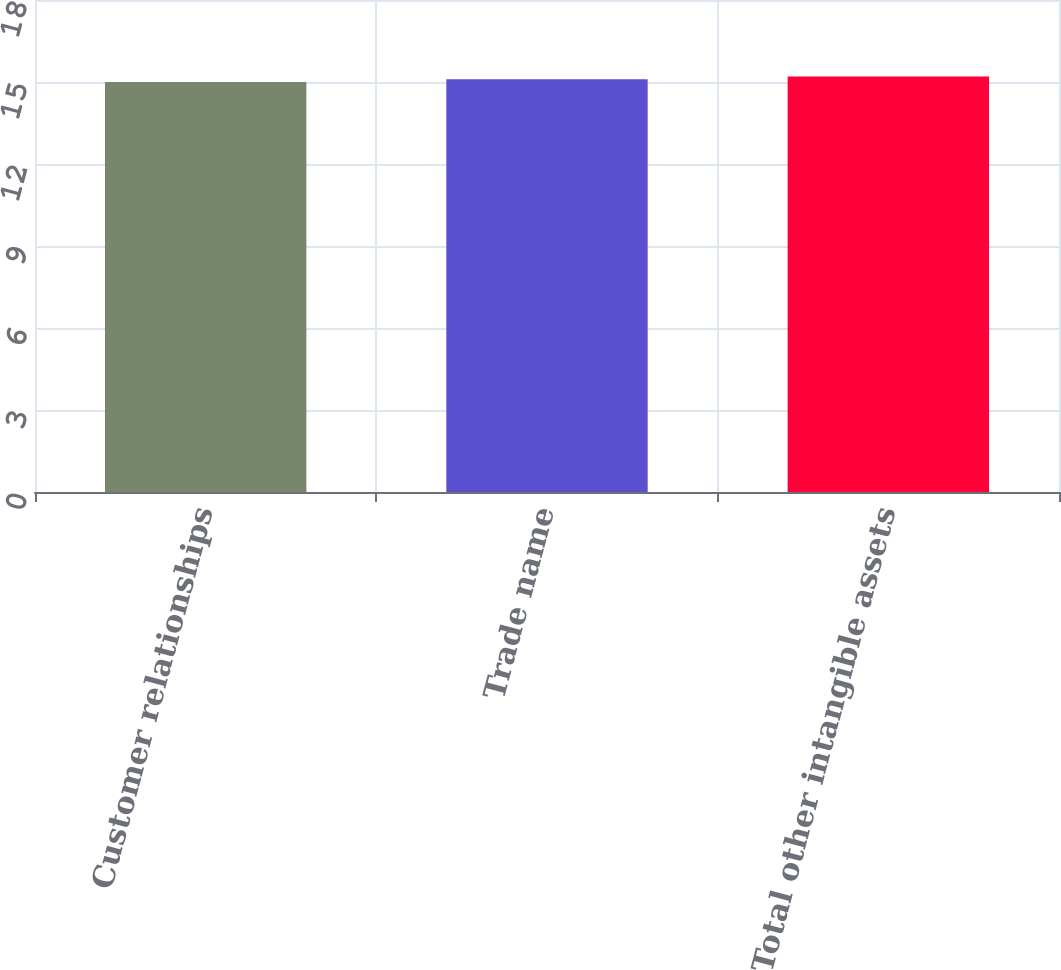<chart> <loc_0><loc_0><loc_500><loc_500><bar_chart><fcel>Customer relationships<fcel>Trade name<fcel>Total other intangible assets<nl><fcel>15<fcel>15.1<fcel>15.2<nl></chart> 